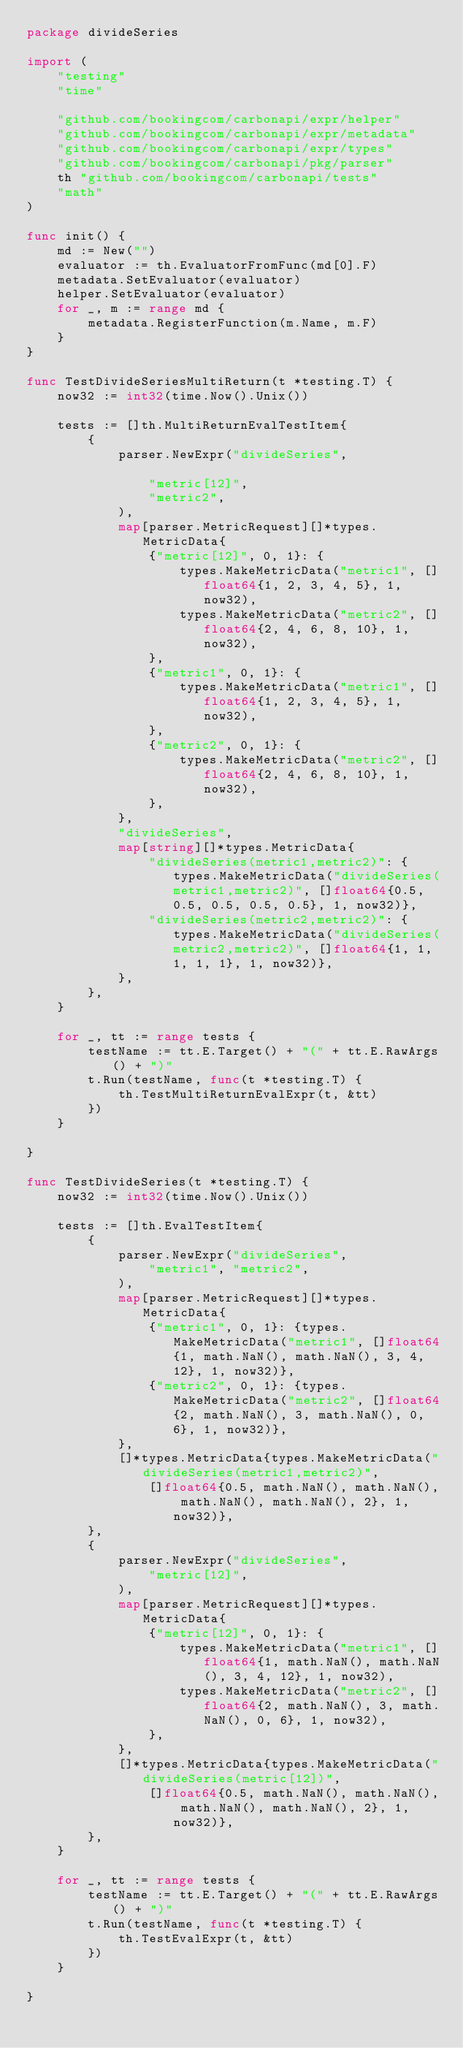Convert code to text. <code><loc_0><loc_0><loc_500><loc_500><_Go_>package divideSeries

import (
	"testing"
	"time"

	"github.com/bookingcom/carbonapi/expr/helper"
	"github.com/bookingcom/carbonapi/expr/metadata"
	"github.com/bookingcom/carbonapi/expr/types"
	"github.com/bookingcom/carbonapi/pkg/parser"
	th "github.com/bookingcom/carbonapi/tests"
	"math"
)

func init() {
	md := New("")
	evaluator := th.EvaluatorFromFunc(md[0].F)
	metadata.SetEvaluator(evaluator)
	helper.SetEvaluator(evaluator)
	for _, m := range md {
		metadata.RegisterFunction(m.Name, m.F)
	}
}

func TestDivideSeriesMultiReturn(t *testing.T) {
	now32 := int32(time.Now().Unix())

	tests := []th.MultiReturnEvalTestItem{
		{
			parser.NewExpr("divideSeries",

				"metric[12]",
				"metric2",
			),
			map[parser.MetricRequest][]*types.MetricData{
				{"metric[12]", 0, 1}: {
					types.MakeMetricData("metric1", []float64{1, 2, 3, 4, 5}, 1, now32),
					types.MakeMetricData("metric2", []float64{2, 4, 6, 8, 10}, 1, now32),
				},
				{"metric1", 0, 1}: {
					types.MakeMetricData("metric1", []float64{1, 2, 3, 4, 5}, 1, now32),
				},
				{"metric2", 0, 1}: {
					types.MakeMetricData("metric2", []float64{2, 4, 6, 8, 10}, 1, now32),
				},
			},
			"divideSeries",
			map[string][]*types.MetricData{
				"divideSeries(metric1,metric2)": {types.MakeMetricData("divideSeries(metric1,metric2)", []float64{0.5, 0.5, 0.5, 0.5, 0.5}, 1, now32)},
				"divideSeries(metric2,metric2)": {types.MakeMetricData("divideSeries(metric2,metric2)", []float64{1, 1, 1, 1, 1}, 1, now32)},
			},
		},
	}

	for _, tt := range tests {
		testName := tt.E.Target() + "(" + tt.E.RawArgs() + ")"
		t.Run(testName, func(t *testing.T) {
			th.TestMultiReturnEvalExpr(t, &tt)
		})
	}

}

func TestDivideSeries(t *testing.T) {
	now32 := int32(time.Now().Unix())

	tests := []th.EvalTestItem{
		{
			parser.NewExpr("divideSeries",
				"metric1", "metric2",
			),
			map[parser.MetricRequest][]*types.MetricData{
				{"metric1", 0, 1}: {types.MakeMetricData("metric1", []float64{1, math.NaN(), math.NaN(), 3, 4, 12}, 1, now32)},
				{"metric2", 0, 1}: {types.MakeMetricData("metric2", []float64{2, math.NaN(), 3, math.NaN(), 0, 6}, 1, now32)},
			},
			[]*types.MetricData{types.MakeMetricData("divideSeries(metric1,metric2)",
				[]float64{0.5, math.NaN(), math.NaN(), math.NaN(), math.NaN(), 2}, 1, now32)},
		},
		{
			parser.NewExpr("divideSeries",
				"metric[12]",
			),
			map[parser.MetricRequest][]*types.MetricData{
				{"metric[12]", 0, 1}: {
					types.MakeMetricData("metric1", []float64{1, math.NaN(), math.NaN(), 3, 4, 12}, 1, now32),
					types.MakeMetricData("metric2", []float64{2, math.NaN(), 3, math.NaN(), 0, 6}, 1, now32),
				},
			},
			[]*types.MetricData{types.MakeMetricData("divideSeries(metric[12])",
				[]float64{0.5, math.NaN(), math.NaN(), math.NaN(), math.NaN(), 2}, 1, now32)},
		},
	}

	for _, tt := range tests {
		testName := tt.E.Target() + "(" + tt.E.RawArgs() + ")"
		t.Run(testName, func(t *testing.T) {
			th.TestEvalExpr(t, &tt)
		})
	}

}
</code> 